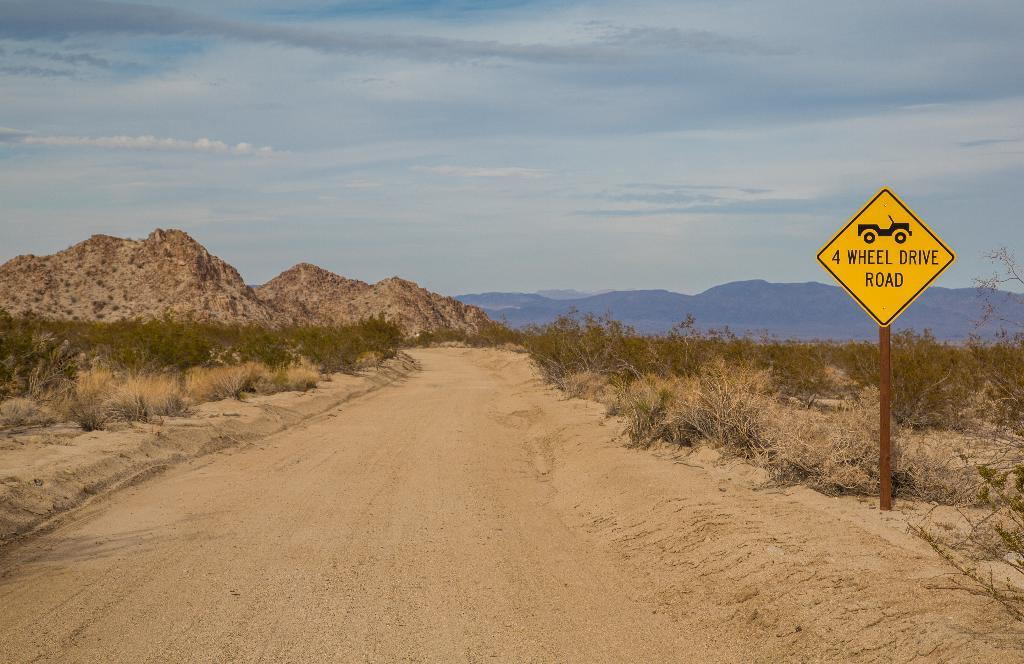<image>
Offer a succinct explanation of the picture presented. A dirt road has a yellow sign next to it that says 4 Wheel Drive Road. 